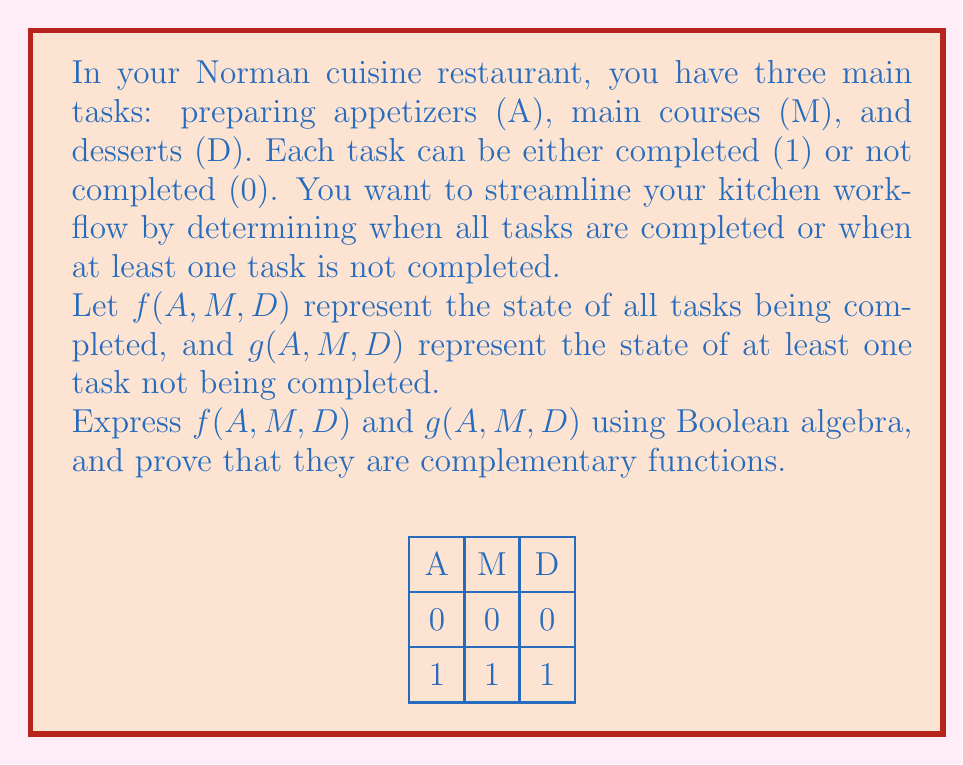Could you help me with this problem? Let's approach this step-by-step:

1) First, let's express $f(A,M,D)$. This function should be true (1) only when all tasks are completed. In Boolean algebra, this is represented by the AND operation:

   $f(A,M,D) = A \cdot M \cdot D$

2) Now, let's express $g(A,M,D)$. This function should be true (1) when at least one task is not completed. We can express this using De Morgan's law:

   $g(A,M,D) = \overline{A \cdot M \cdot D} = \overline{A} + \overline{M} + \overline{D}$

3) To prove that $f$ and $g$ are complementary, we need to show that:
   
   $f(A,M,D) + g(A,M,D) = 1$ (their sum is always 1)
   $f(A,M,D) \cdot g(A,M,D) = 0$ (their product is always 0)

4) Let's prove the first condition:

   $f(A,M,D) + g(A,M,D) = (A \cdot M \cdot D) + (\overline{A} + \overline{M} + \overline{D})$
   
   This is true by the definition of complementary functions in Boolean algebra.

5) Now, let's prove the second condition:

   $f(A,M,D) \cdot g(A,M,D) = (A \cdot M \cdot D) \cdot (\overline{A} + \overline{M} + \overline{D})$
   
   Distributing the AND operation:
   
   $(A \cdot M \cdot D \cdot \overline{A}) + (A \cdot M \cdot D \cdot \overline{M}) + (A \cdot M \cdot D \cdot \overline{D})$
   
   Each term contains a variable AND its complement, which always evaluates to 0:
   
   $0 + 0 + 0 = 0$

Therefore, we have proven that $f(A,M,D)$ and $g(A,M,D)$ are indeed complementary functions.
Answer: $f(A,M,D) = A \cdot M \cdot D$, $g(A,M,D) = \overline{A} + \overline{M} + \overline{D}$ 